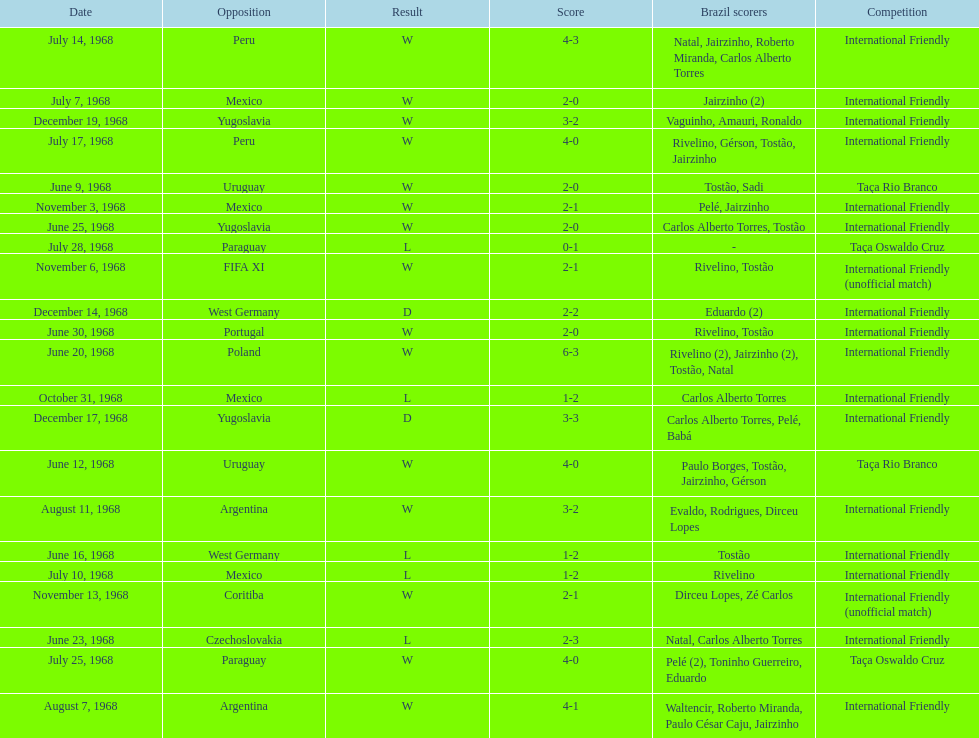How many times did brazil score during the game on november 6th? 2. 